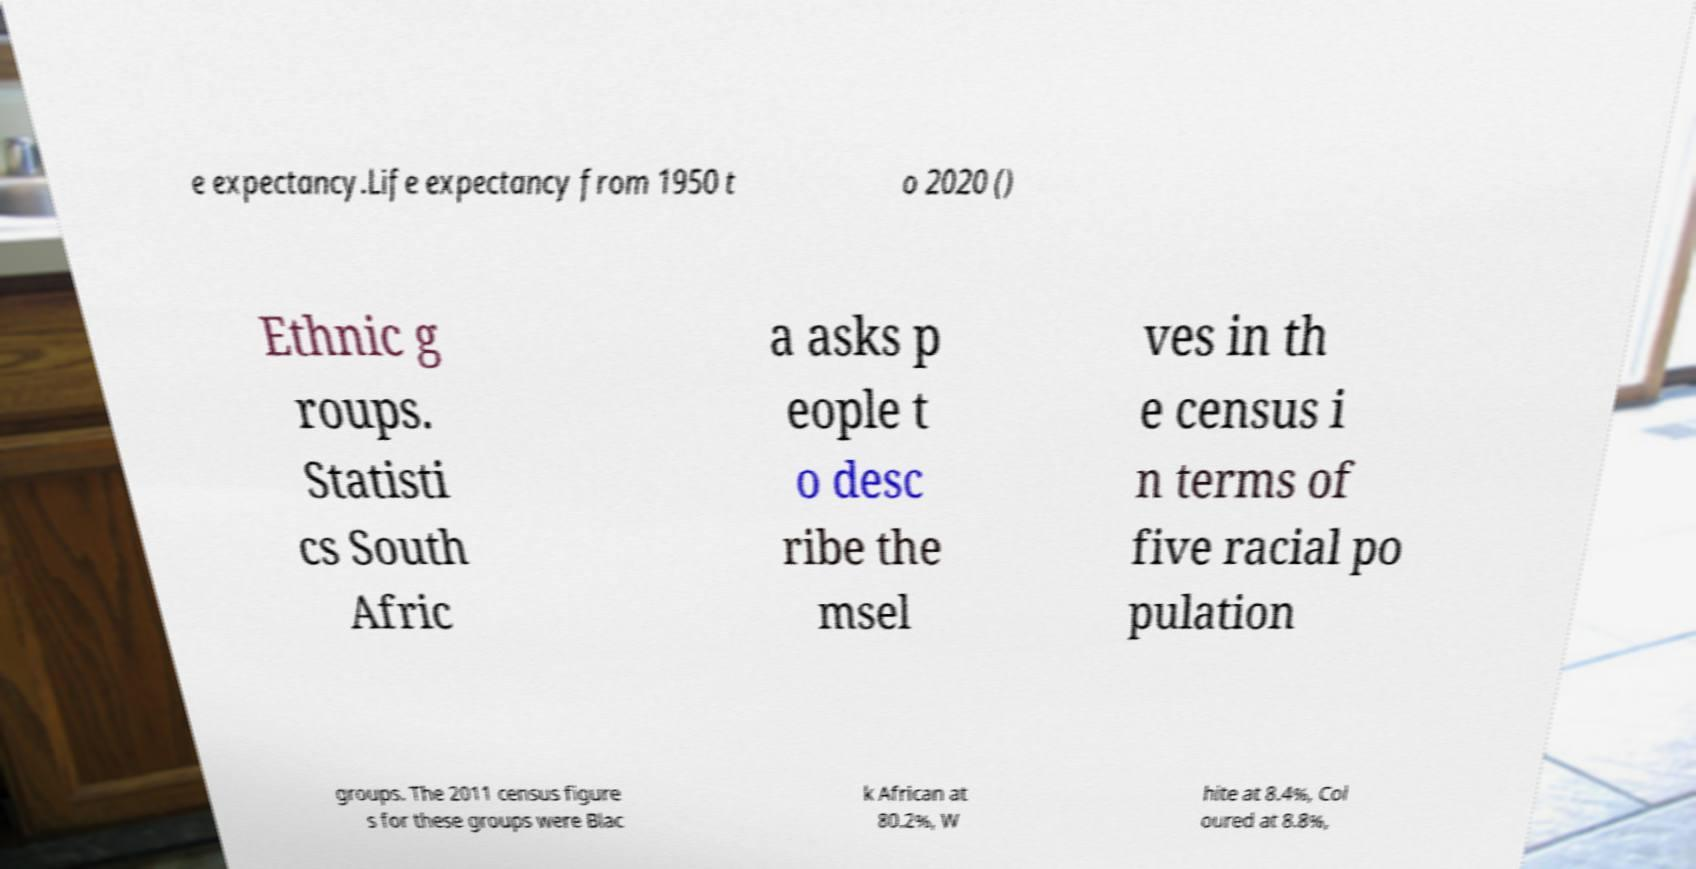Please identify and transcribe the text found in this image. e expectancy.Life expectancy from 1950 t o 2020 () Ethnic g roups. Statisti cs South Afric a asks p eople t o desc ribe the msel ves in th e census i n terms of five racial po pulation groups. The 2011 census figure s for these groups were Blac k African at 80.2%, W hite at 8.4%, Col oured at 8.8%, 